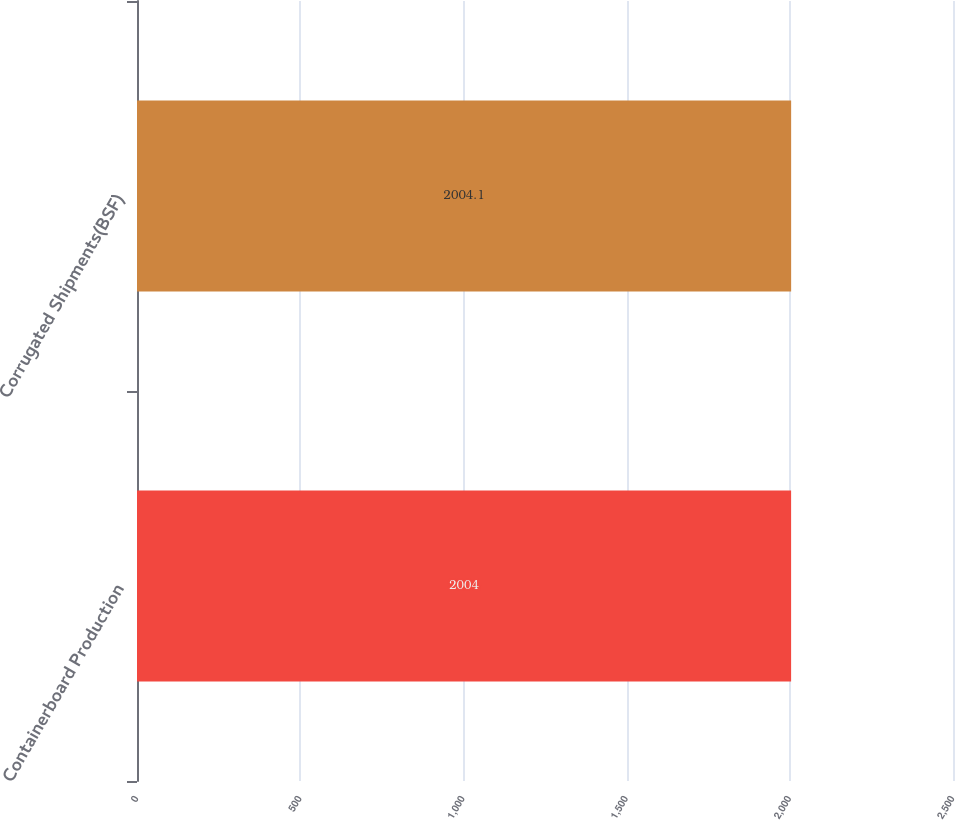<chart> <loc_0><loc_0><loc_500><loc_500><bar_chart><fcel>Containerboard Production<fcel>Corrugated Shipments(BSF)<nl><fcel>2004<fcel>2004.1<nl></chart> 